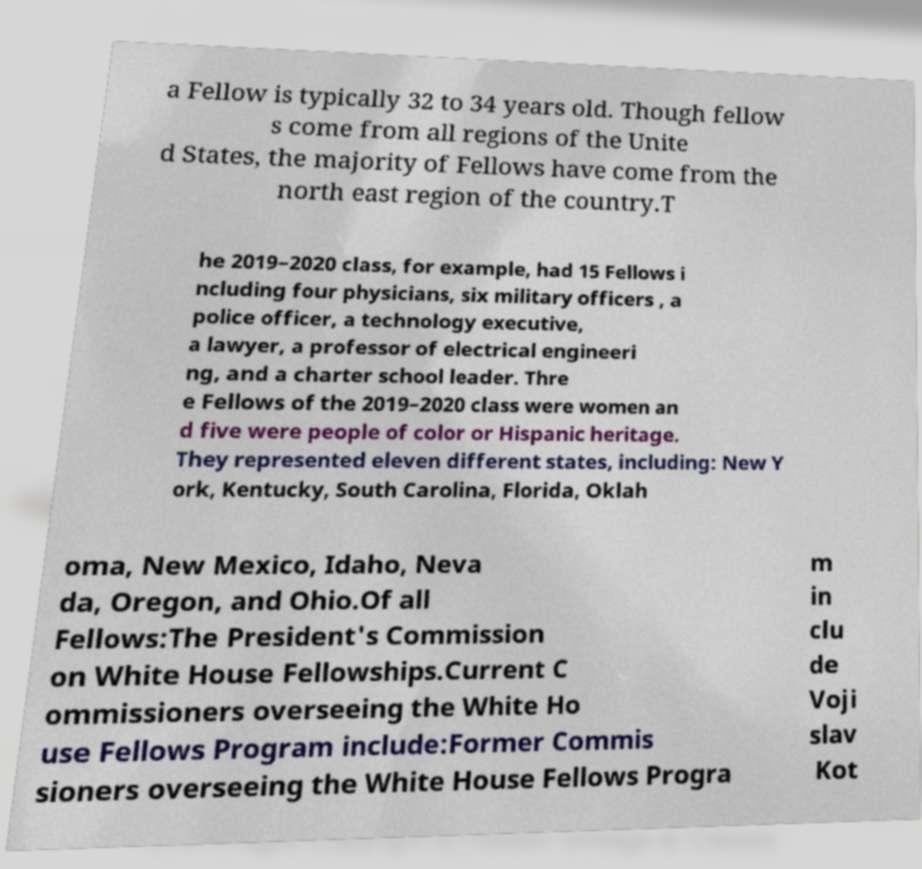There's text embedded in this image that I need extracted. Can you transcribe it verbatim? a Fellow is typically 32 to 34 years old. Though fellow s come from all regions of the Unite d States, the majority of Fellows have come from the north east region of the country.T he 2019–2020 class, for example, had 15 Fellows i ncluding four physicians, six military officers , a police officer, a technology executive, a lawyer, a professor of electrical engineeri ng, and a charter school leader. Thre e Fellows of the 2019–2020 class were women an d five were people of color or Hispanic heritage. They represented eleven different states, including: New Y ork, Kentucky, South Carolina, Florida, Oklah oma, New Mexico, Idaho, Neva da, Oregon, and Ohio.Of all Fellows:The President's Commission on White House Fellowships.Current C ommissioners overseeing the White Ho use Fellows Program include:Former Commis sioners overseeing the White House Fellows Progra m in clu de Voji slav Kot 